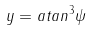<formula> <loc_0><loc_0><loc_500><loc_500>y = a t a n ^ { 3 } \psi</formula> 